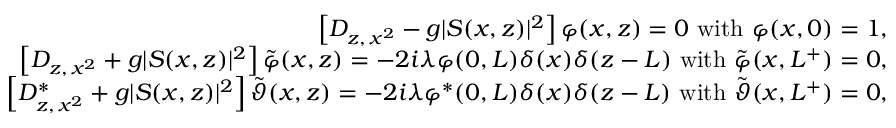Convert formula to latex. <formula><loc_0><loc_0><loc_500><loc_500>\begin{array} { r l r } & { \left [ D _ { z , \, x ^ { 2 } } - g | S ( x , z ) | ^ { 2 } \right ] \varphi ( x , z ) = 0 \ w i t h \ \varphi ( x , 0 ) = 1 , } \\ & { \left [ D _ { z , \, x ^ { 2 } } + g | S ( x , z ) | ^ { 2 } \right ] \tilde { \varphi } ( x , z ) = - 2 i \lambda \varphi ( 0 , L ) \delta ( x ) \delta ( z - L ) \ w i t h \ \tilde { \varphi } ( x , L ^ { + } ) = 0 , } \\ & { \left [ D _ { z , \, x ^ { 2 } } ^ { \ast } + g | S ( x , z ) | ^ { 2 } \right ] \tilde { \vartheta } ( x , z ) = - 2 i \lambda \varphi ^ { \ast } ( 0 , L ) \delta ( x ) \delta ( z - L ) \ w i t h \ \tilde { \vartheta } ( x , L ^ { + } ) = 0 , } \end{array}</formula> 